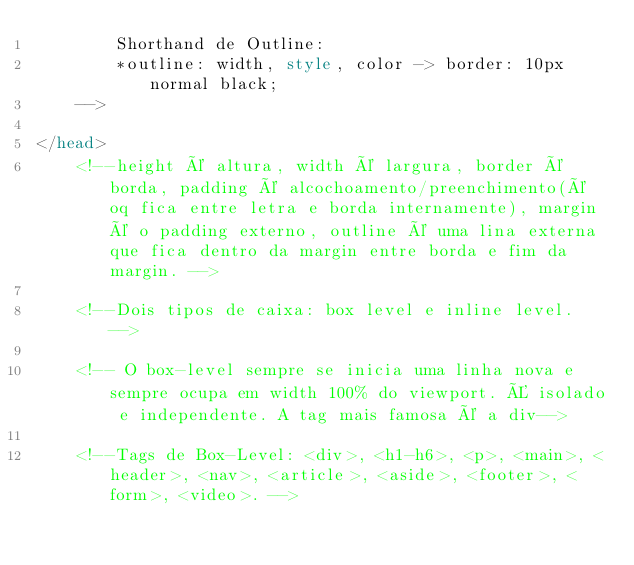<code> <loc_0><loc_0><loc_500><loc_500><_HTML_>        Shorthand de Outline: 
        *outline: width, style, color -> border: 10px normal black;
    -->
    
</head>
    <!--height é altura, width é largura, border é borda, padding é alcochoamento/preenchimento(é oq fica entre letra e borda internamente), margin é o padding externo, outline é uma lina externa que fica dentro da margin entre borda e fim da margin. -->

    <!--Dois tipos de caixa: box level e inline level. -->

    <!-- O box-level sempre se inicia uma linha nova e sempre ocupa em width 100% do viewport. É isolado e independente. A tag mais famosa é a div-->

    <!--Tags de Box-Level: <div>, <h1-h6>, <p>, <main>, <header>, <nav>, <article>, <aside>, <footer>, <form>, <video>. -->
</code> 